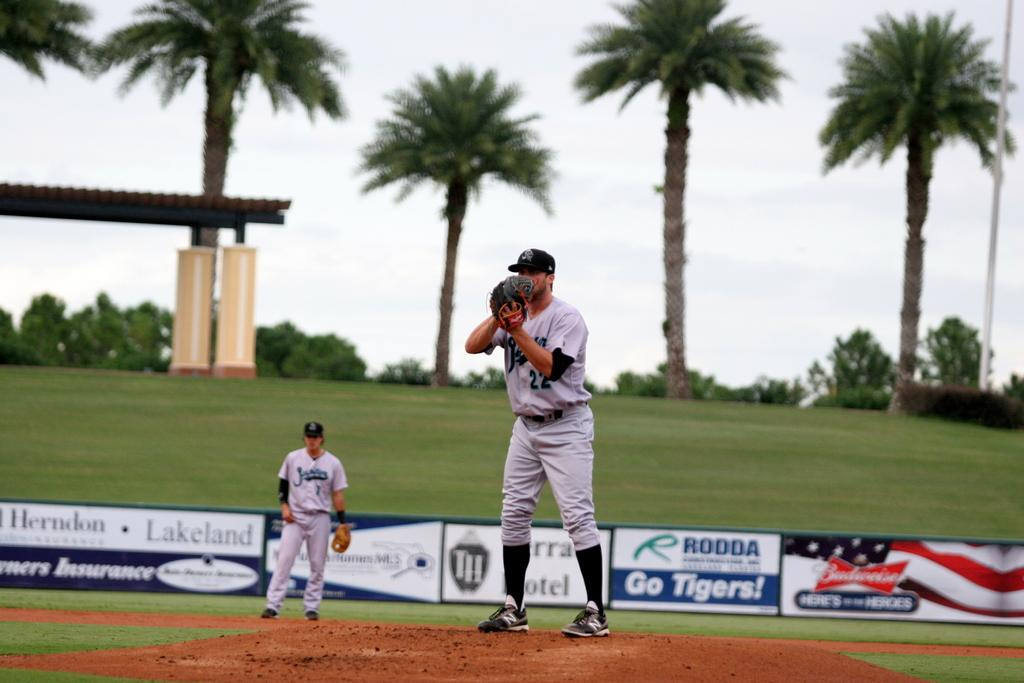Provide a one-sentence caption for the provided image. Budweiser advertises at the Tigers minor league stadium. 